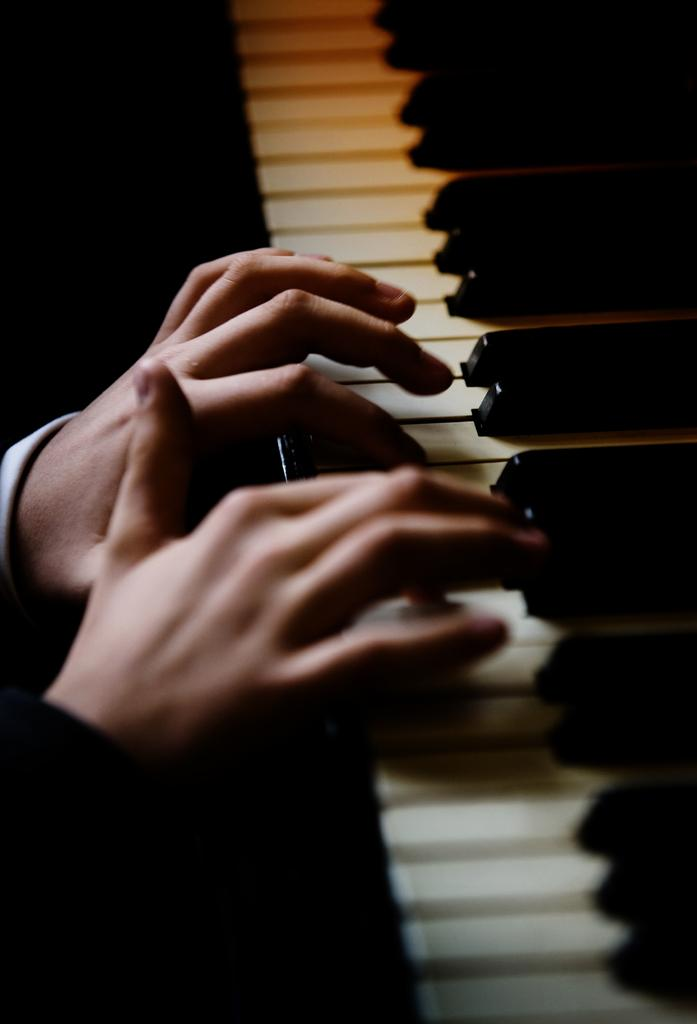What is the main subject of the image? There is a person in the image. What is the person doing in the image? The person is playing a piano. What grade did the person receive for their piano performance in the image? There is no indication of a performance or grade in the image; it simply shows a person playing a piano. Can you see the person's smile while playing the piano in the image? The image does not show the person's facial expression, so it cannot be determined if they are smiling or not. 